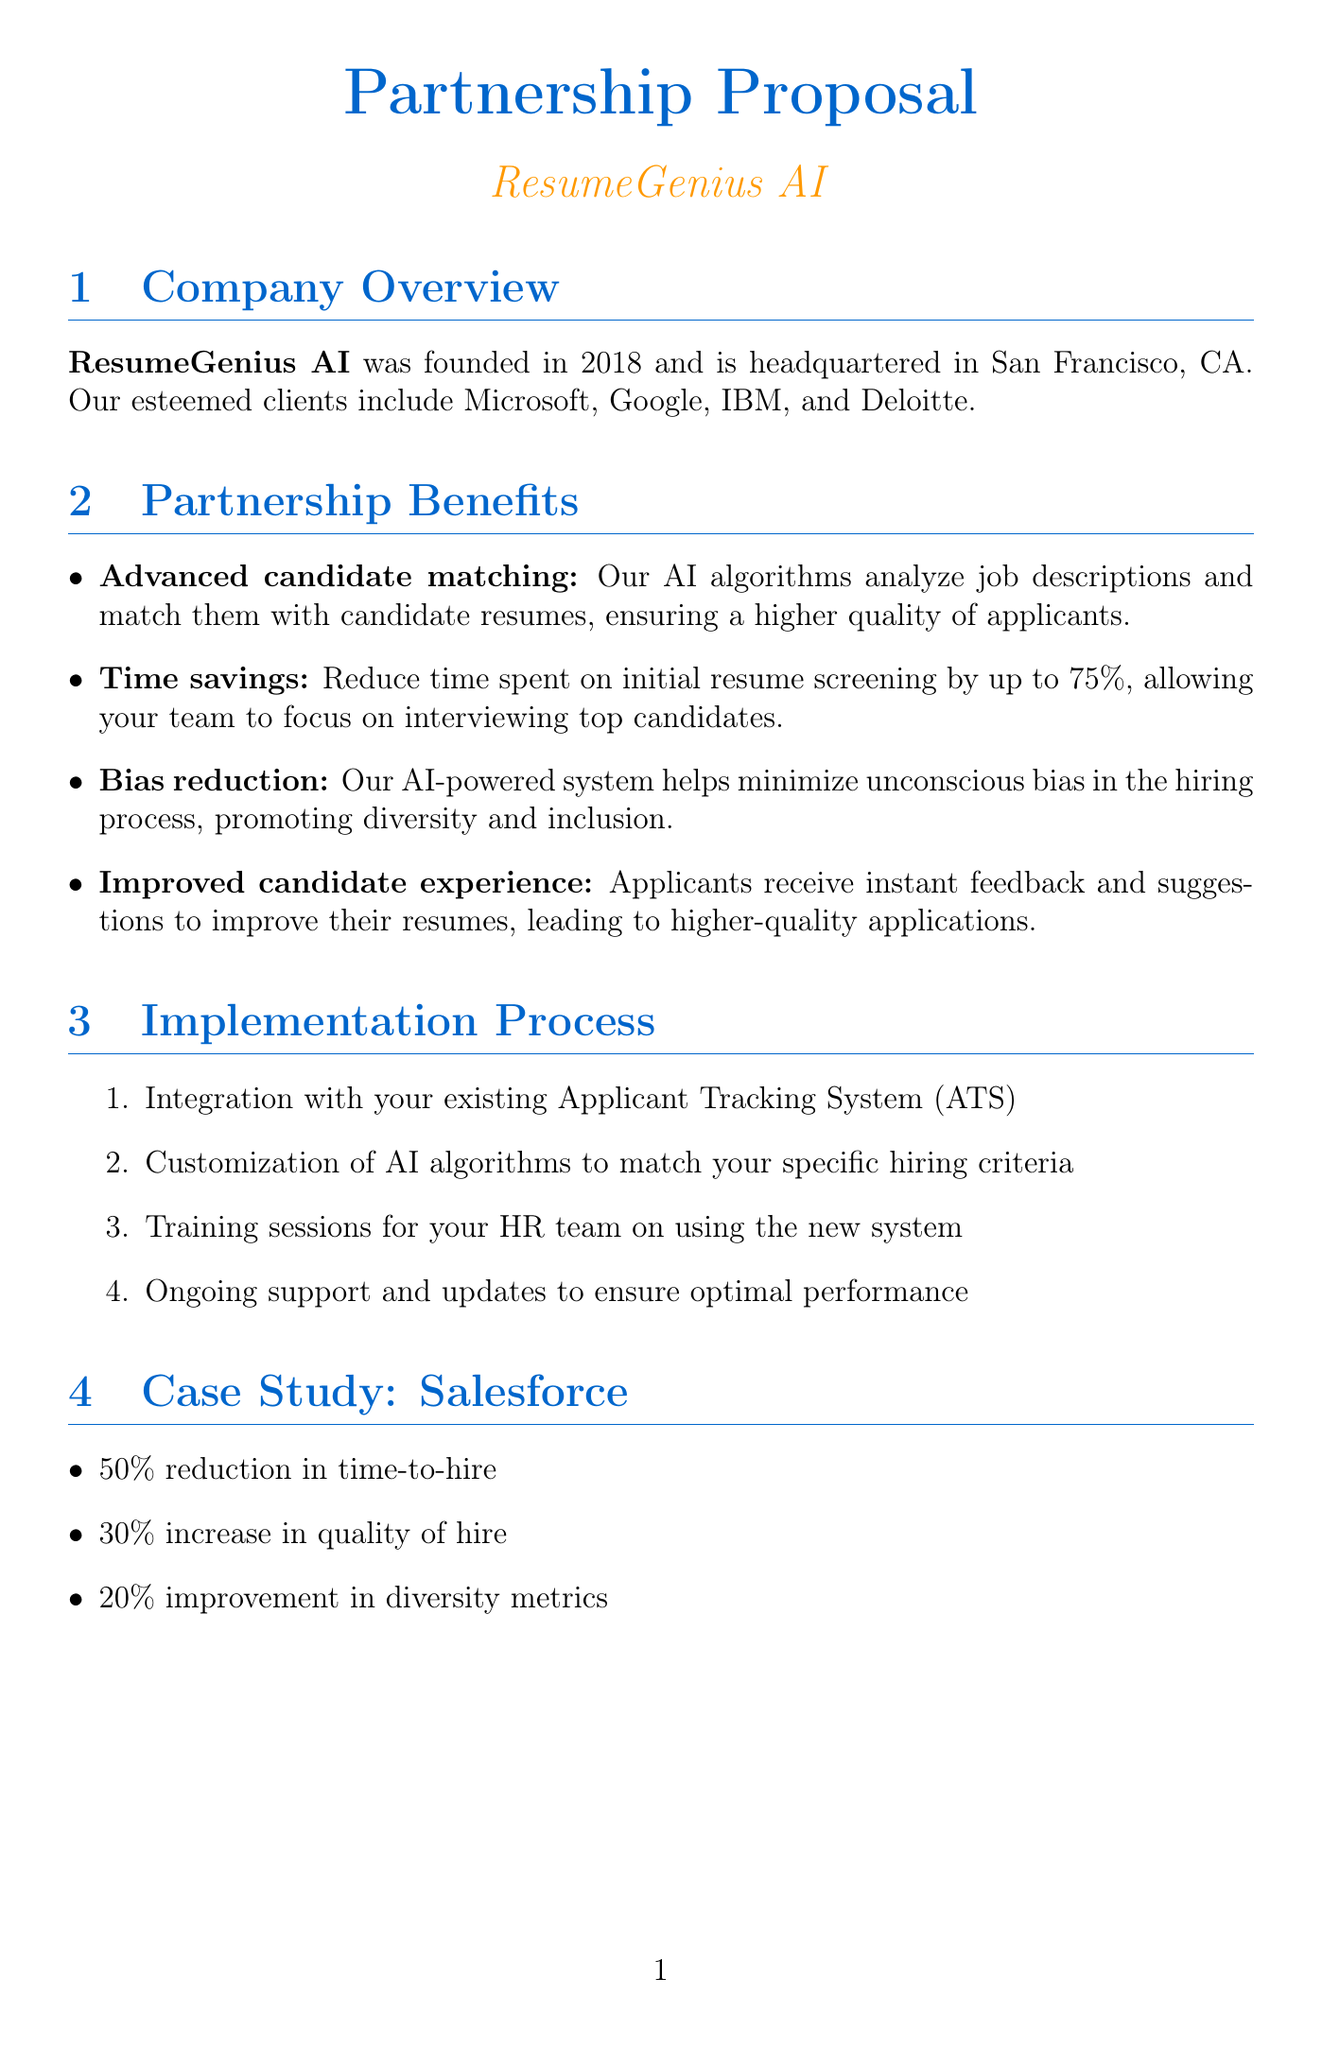What year was ResumeGenius AI founded? The founding year is mentioned in the document, which is 2018.
Answer: 2018 What is the price of the Pro plan? The document lists the price for the Pro plan as $5,000/month.
Answer: $5,000/month Which company is mentioned in the case study? The case study section specifically mentions Salesforce as the client.
Answer: Salesforce What is one benefit related to candidate experience? The document states that applicants receive instant feedback and suggestions to improve their resumes.
Answer: Improved candidate experience How much time can be saved in resume screening? The time savings benefit quantifies a reduction of up to 75% in initial resume screening.
Answer: 75% What kind of support does the Enterprise plan include? The Enterprise plan includes dedicated support according to the features listed.
Answer: Dedicated support What are the first two steps in the implementation process? The implementation process begins with integration with the existing ATS and customization of AI algorithms.
Answer: Integration with your existing Applicant Tracking System (ATS), Customization of AI algorithms What did Sarah Thompson say about ResumeGenius AI? The document includes a quote from Sarah Thompson praising the efficiency of the hiring process.
Answer: "ResumeGenius AI has revolutionized our hiring process." 